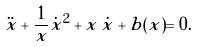<formula> <loc_0><loc_0><loc_500><loc_500>\ddot { x } + \frac { 1 } { x } \dot { x } ^ { 2 } + x \, \dot { x } + b ( x ) = 0 .</formula> 